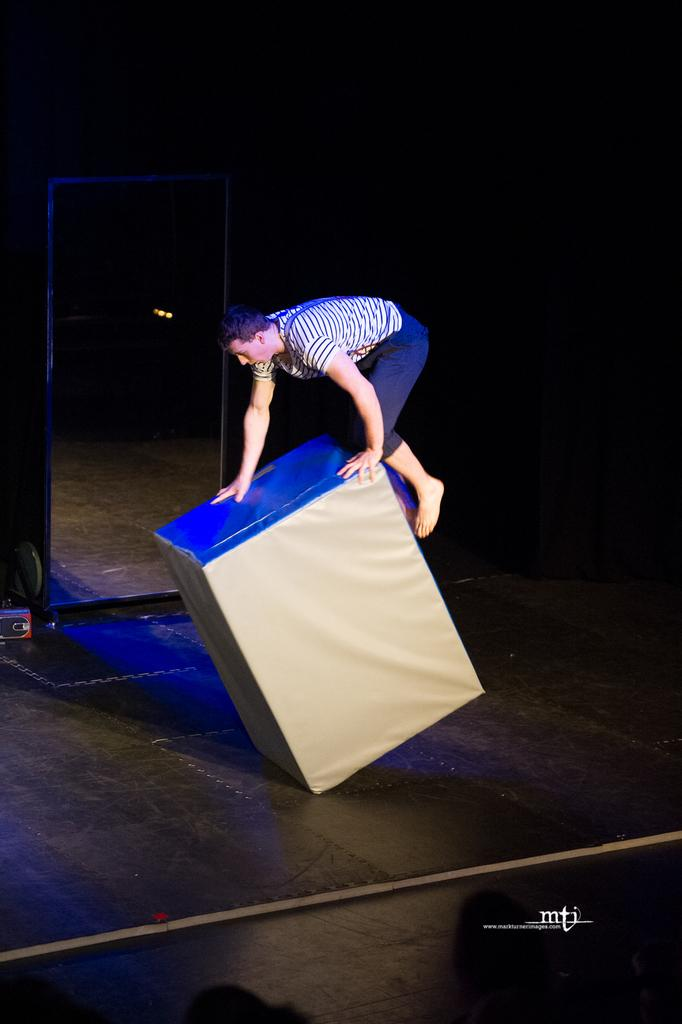What is the main subject of the image? The main subject of the image is a person. What is the person doing in the image? The person is climbing on an object. What can be observed about the background of the image? The background of the image is dark. How many houses can be seen in the image? There are no houses visible in the image. What type of mice can be seen interacting with the person in the image? There are no mice present in the image. What can the person in the image use to store their belongings? The provided facts do not mention any can or storage object in the image. 